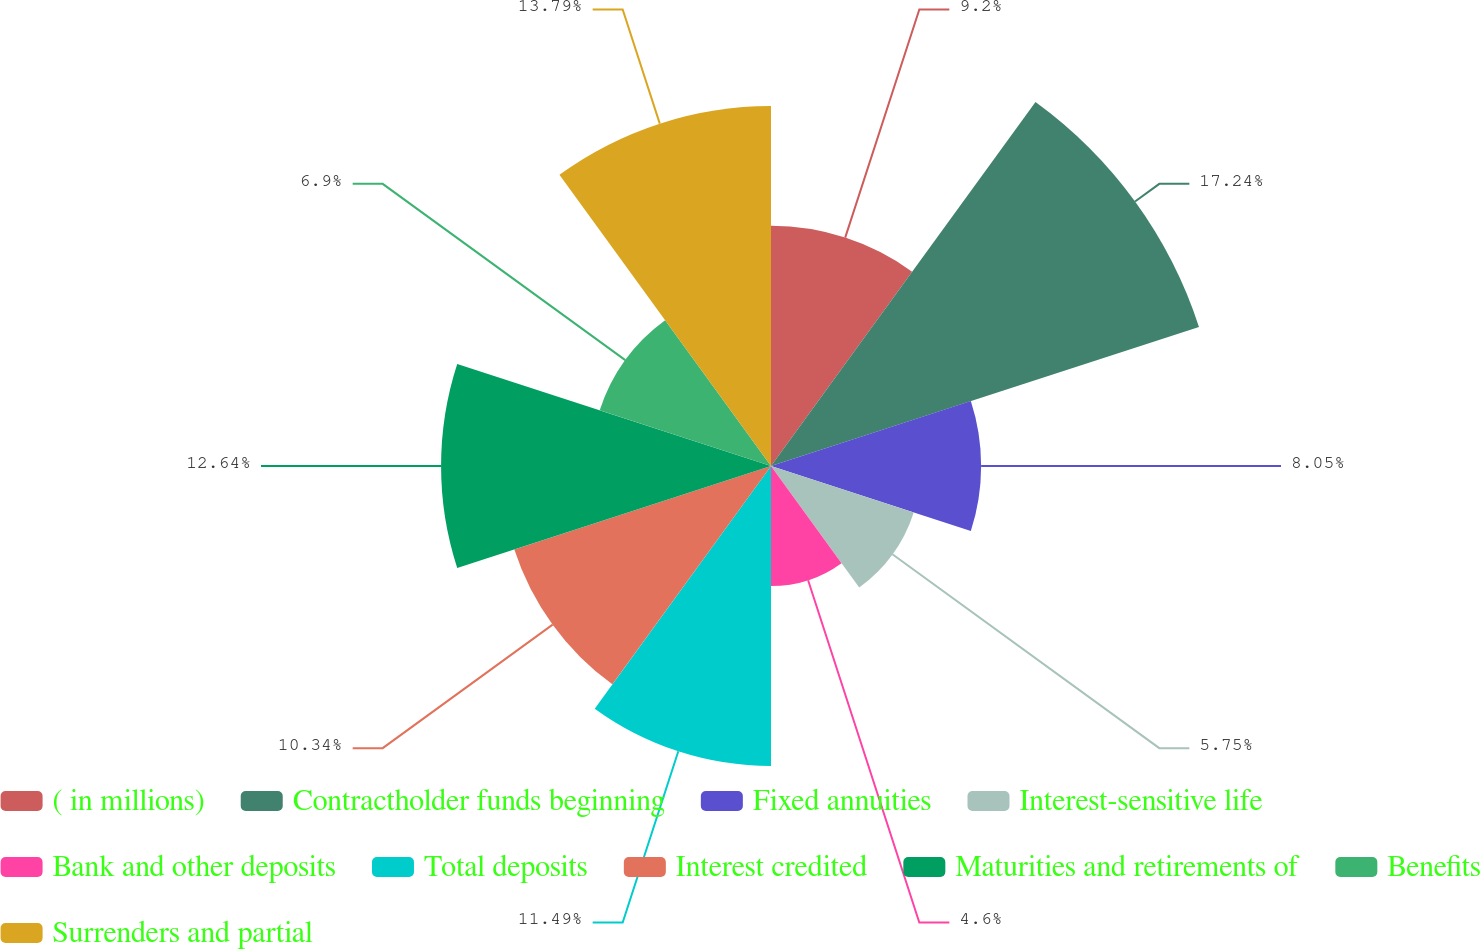<chart> <loc_0><loc_0><loc_500><loc_500><pie_chart><fcel>( in millions)<fcel>Contractholder funds beginning<fcel>Fixed annuities<fcel>Interest-sensitive life<fcel>Bank and other deposits<fcel>Total deposits<fcel>Interest credited<fcel>Maturities and retirements of<fcel>Benefits<fcel>Surrenders and partial<nl><fcel>9.2%<fcel>17.24%<fcel>8.05%<fcel>5.75%<fcel>4.6%<fcel>11.49%<fcel>10.34%<fcel>12.64%<fcel>6.9%<fcel>13.79%<nl></chart> 